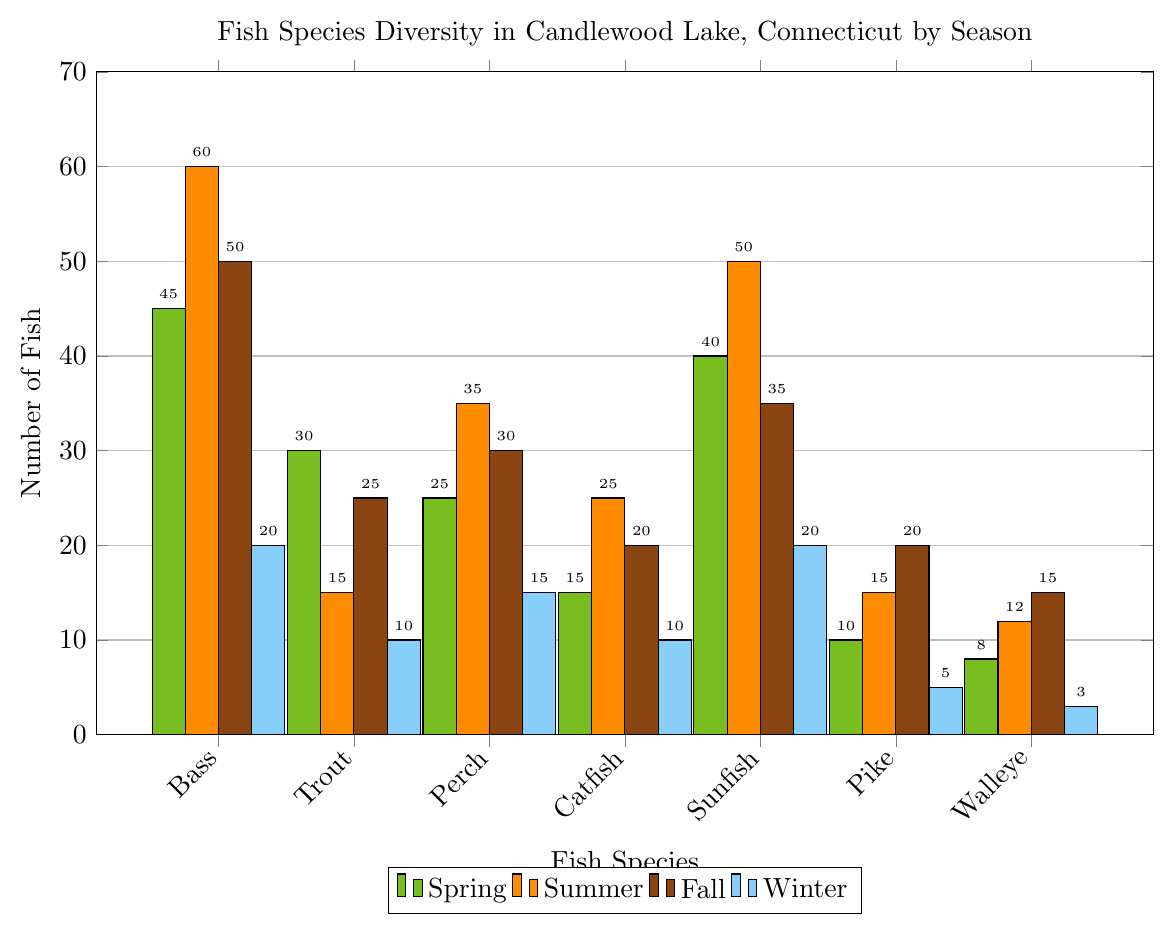What's the total number of Sunfish across all seasons? To find the total number of Sunfish, add the counts from each season: Spring (40), Summer (50), Fall (35), and Winter (20). Summing these gives 40 + 50 + 35 + 20.
Answer: 145 Which season has the highest number of Bass? Compare the number of Bass across all seasons: Spring (45), Summer (60), Fall (50), Winter (20). The highest number is 60 Bass in Summer.
Answer: Summer How many more Pike are there in Fall than in Winter? The number of Pike in Fall is 20 and in Winter is 5. The difference is 20 - 5.
Answer: 15 What are the total counts of fish in Winter? Add the counts of each species in Winter: Bass (20), Trout (10), Perch (15), Catfish (10), Sunfish (20), Pike (5), Walleye (3). Summing these gives 20 + 10 + 15 + 10 + 20 + 5 + 3.
Answer: 83 Which fish species has the smallest population in Spring? Compare the population of each species in Spring: Bass (45), Trout (30), Perch (25), Catfish (15), Sunfish (40), Pike (10), Walleye (8). The smallest population is Walleye with 8.
Answer: Walleye Are there more Catfish or Perch in Summer? Compare the counts for Summer: Catfish (25) and Perch (35). Perch have a higher number than Catfish.
Answer: Perch How does the number of Walleye in Summer compare to Spring? In Summer, there are 12 Walleye, and in Spring, there are 8. 12 is greater than 8.
Answer: Summer has more Which season has the smallest variety of fish counts? The smallest variety means the season with the least range in fish counts. Calculate the range (max - min) for each season. Spring (45-8), Summer (60-12), Fall (50-15), Winter (20-3). Winter has the smallest range (20-3 = 17).
Answer: Winter 